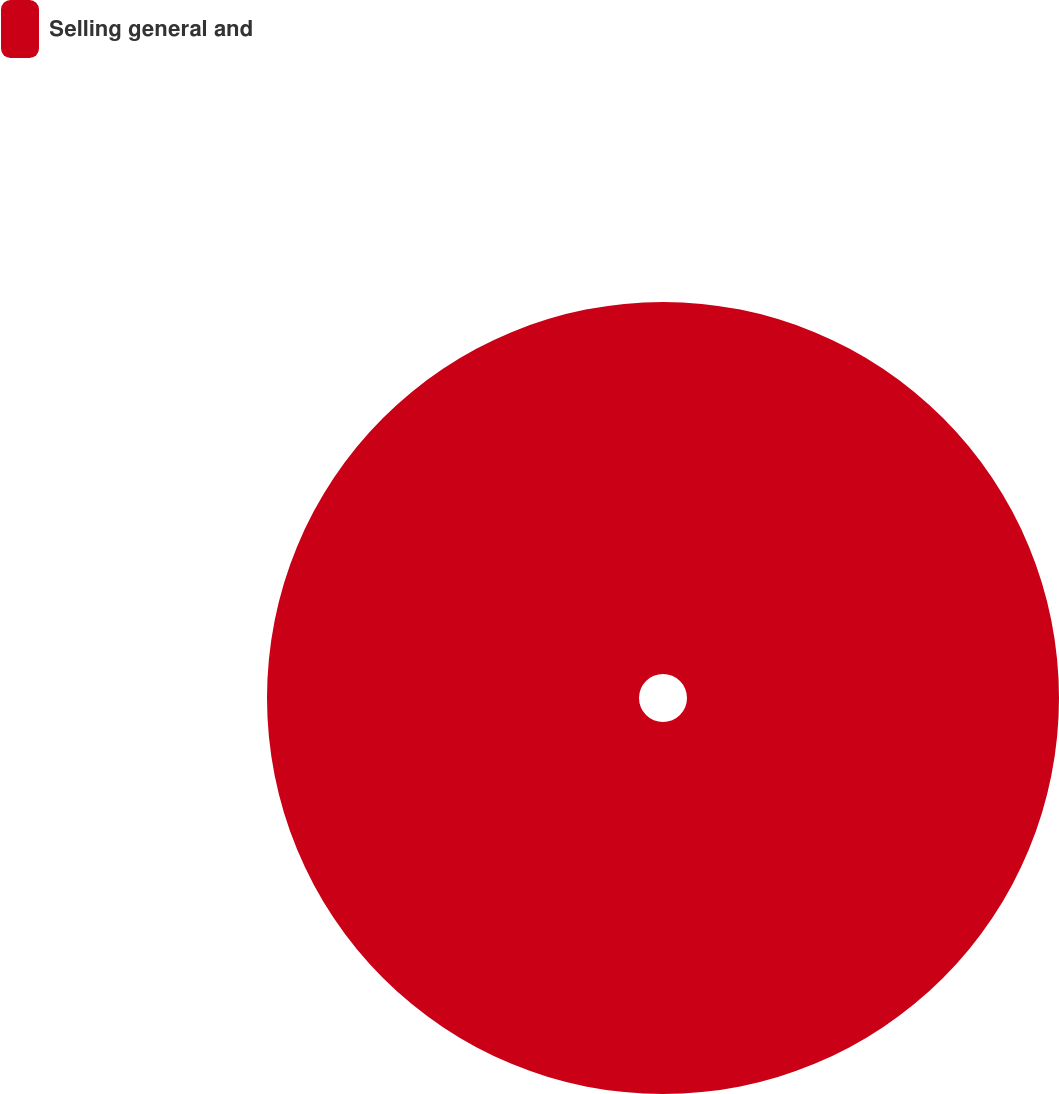Convert chart to OTSL. <chart><loc_0><loc_0><loc_500><loc_500><pie_chart><fcel>Selling general and<nl><fcel>100.0%<nl></chart> 